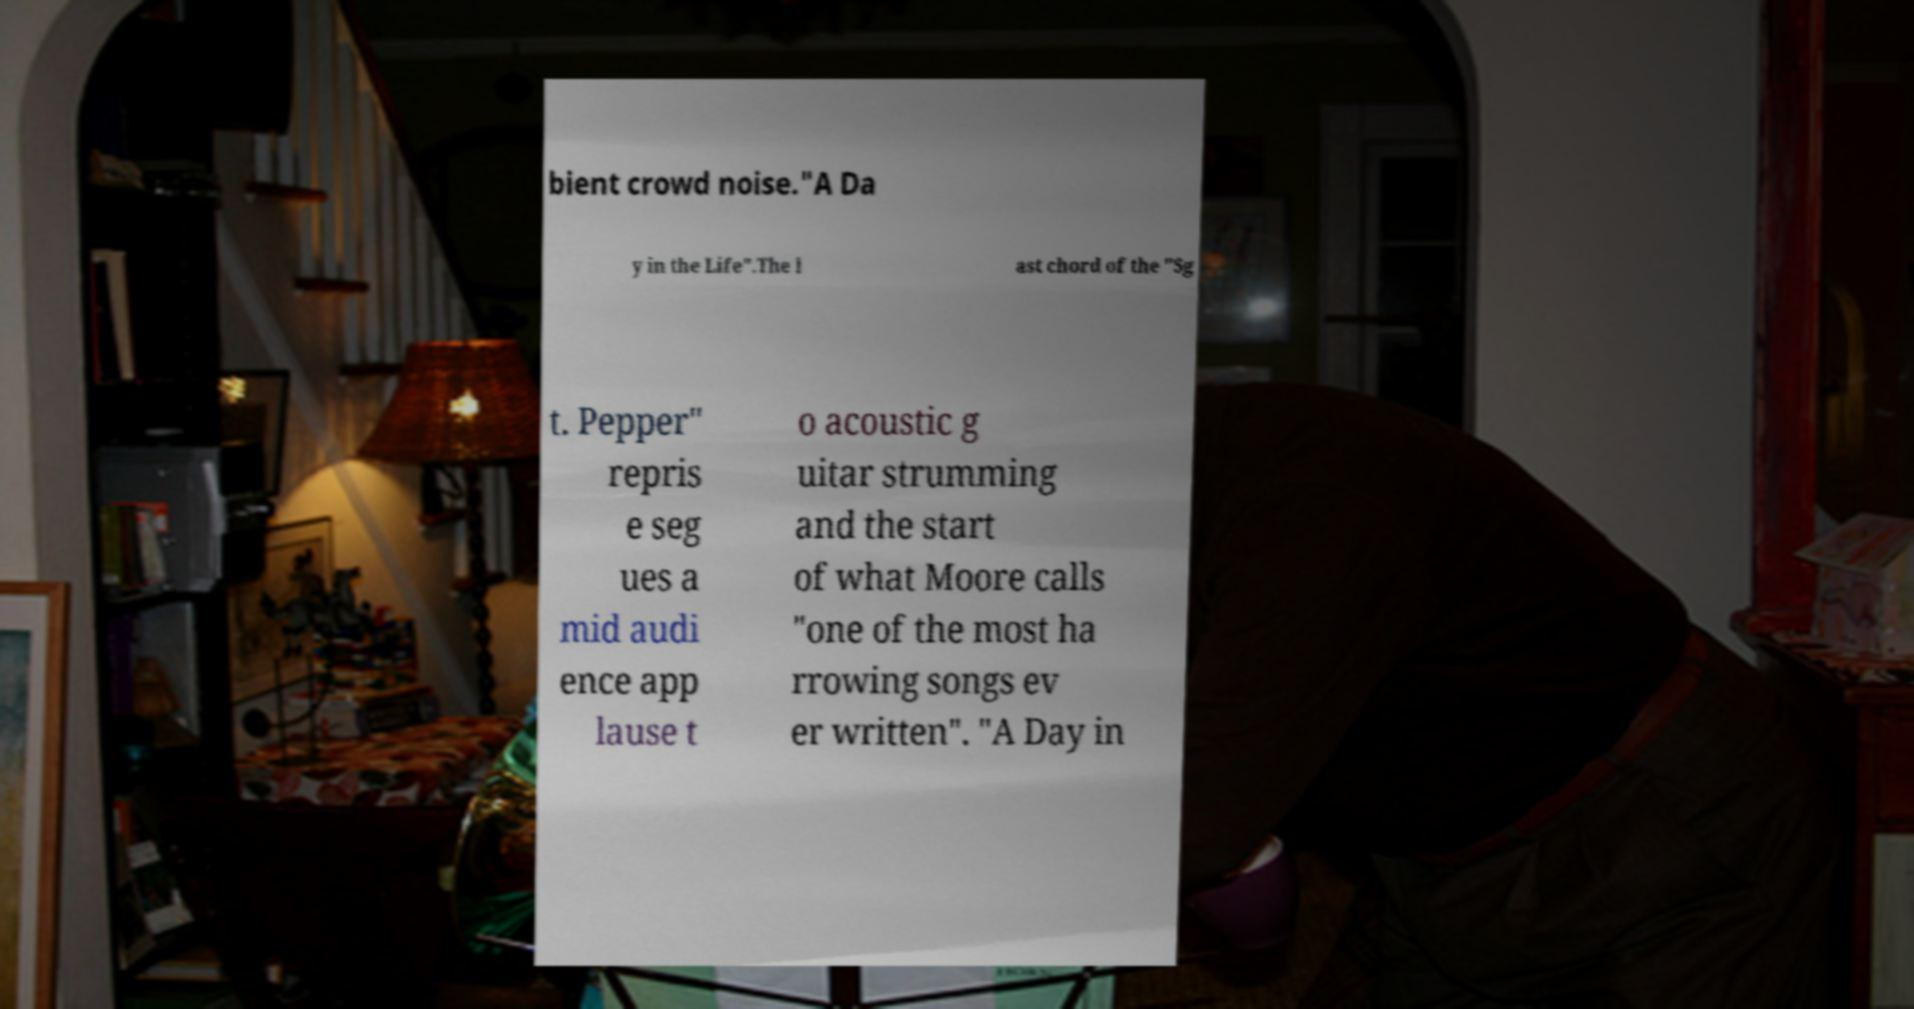Please identify and transcribe the text found in this image. bient crowd noise."A Da y in the Life".The l ast chord of the "Sg t. Pepper" repris e seg ues a mid audi ence app lause t o acoustic g uitar strumming and the start of what Moore calls "one of the most ha rrowing songs ev er written". "A Day in 